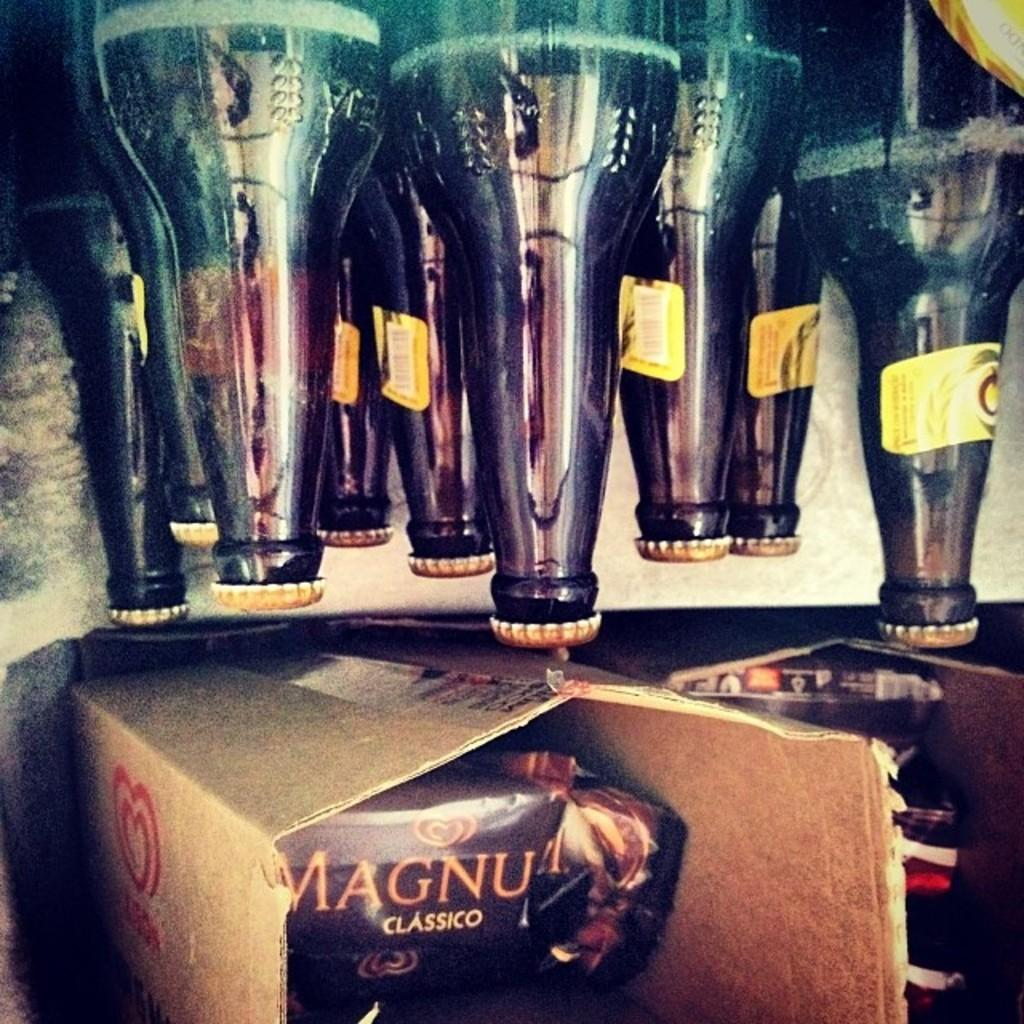What objects are present in the image? There are bottles and cardboard boxes in the image. Can you describe the location of the cardboard boxes in the image? The cardboard boxes are at the bottom in the image. What type of metal is used to construct the cardboard boxes in the image? The cardboard boxes are not made of metal; they are made of cardboard, as indicated by the fact. Is there a list of items visible in the image? There is no mention of a list of items in the provided facts, so it cannot be determined if one is present in the image. 